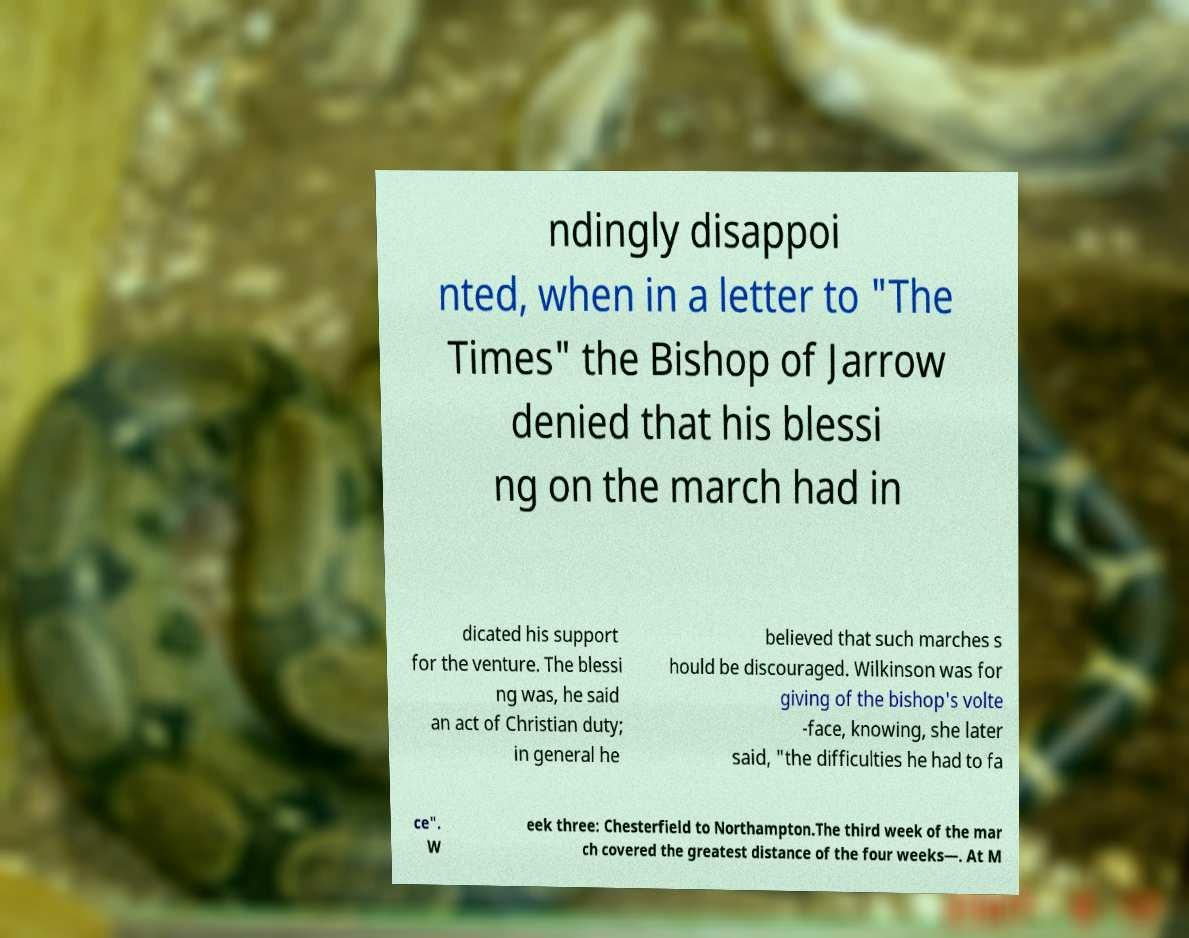Could you extract and type out the text from this image? ndingly disappoi nted, when in a letter to "The Times" the Bishop of Jarrow denied that his blessi ng on the march had in dicated his support for the venture. The blessi ng was, he said an act of Christian duty; in general he believed that such marches s hould be discouraged. Wilkinson was for giving of the bishop's volte -face, knowing, she later said, "the difficulties he had to fa ce". W eek three: Chesterfield to Northampton.The third week of the mar ch covered the greatest distance of the four weeks—. At M 